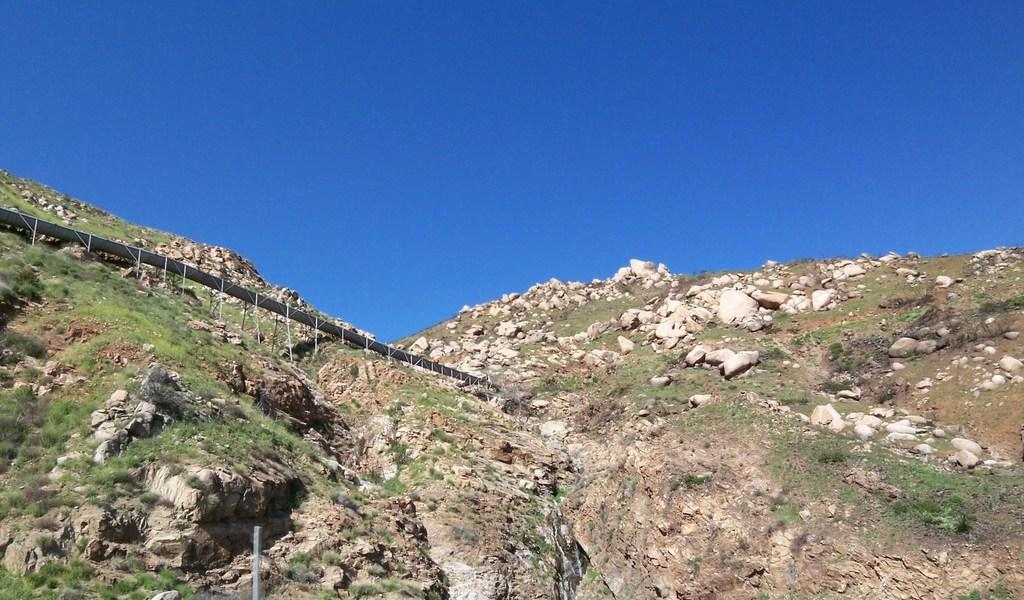What type of landscape feature is present in the image? There is a hill in the image. What structure can be seen on the left side of the image? There appears to be a bridge on the left side of the image. What is visible at the top of the image? The sky is visible at the top of the image. What type of yard can be seen near the bridge in the image? There is no yard present in the image; it features a hill and a bridge. What is the reason for the current flowing under the bridge in the image? There is no current or flowing water present in the image; it only shows a bridge and a hill. 